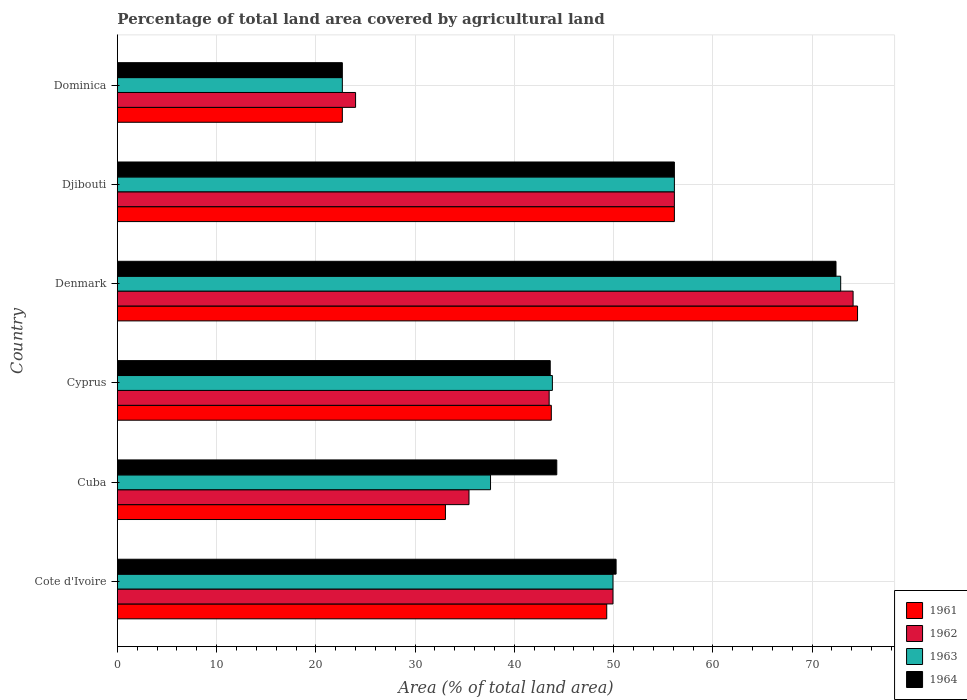Are the number of bars per tick equal to the number of legend labels?
Provide a succinct answer. Yes. Are the number of bars on each tick of the Y-axis equal?
Provide a short and direct response. Yes. How many bars are there on the 2nd tick from the top?
Ensure brevity in your answer.  4. How many bars are there on the 3rd tick from the bottom?
Provide a succinct answer. 4. What is the label of the 2nd group of bars from the top?
Your response must be concise. Djibouti. What is the percentage of agricultural land in 1963 in Cote d'Ivoire?
Your answer should be very brief. 49.94. Across all countries, what is the maximum percentage of agricultural land in 1962?
Give a very brief answer. 74.13. Across all countries, what is the minimum percentage of agricultural land in 1963?
Your response must be concise. 22.67. In which country was the percentage of agricultural land in 1962 maximum?
Give a very brief answer. Denmark. In which country was the percentage of agricultural land in 1964 minimum?
Provide a short and direct response. Dominica. What is the total percentage of agricultural land in 1962 in the graph?
Keep it short and to the point. 283.13. What is the difference between the percentage of agricultural land in 1963 in Denmark and that in Djibouti?
Provide a short and direct response. 16.76. What is the difference between the percentage of agricultural land in 1964 in Denmark and the percentage of agricultural land in 1961 in Djibouti?
Your response must be concise. 16.28. What is the average percentage of agricultural land in 1961 per country?
Offer a terse response. 46.58. What is the difference between the percentage of agricultural land in 1964 and percentage of agricultural land in 1963 in Cote d'Ivoire?
Offer a terse response. 0.31. In how many countries, is the percentage of agricultural land in 1964 greater than 24 %?
Give a very brief answer. 5. What is the ratio of the percentage of agricultural land in 1961 in Cyprus to that in Denmark?
Your answer should be very brief. 0.59. Is the difference between the percentage of agricultural land in 1964 in Cyprus and Djibouti greater than the difference between the percentage of agricultural land in 1963 in Cyprus and Djibouti?
Keep it short and to the point. No. What is the difference between the highest and the second highest percentage of agricultural land in 1964?
Offer a very short reply. 16.28. What is the difference between the highest and the lowest percentage of agricultural land in 1964?
Ensure brevity in your answer.  49.74. Is the sum of the percentage of agricultural land in 1962 in Cuba and Denmark greater than the maximum percentage of agricultural land in 1963 across all countries?
Make the answer very short. Yes. Is it the case that in every country, the sum of the percentage of agricultural land in 1962 and percentage of agricultural land in 1961 is greater than the sum of percentage of agricultural land in 1963 and percentage of agricultural land in 1964?
Provide a succinct answer. No. What does the 3rd bar from the bottom in Cuba represents?
Make the answer very short. 1963. How many bars are there?
Provide a short and direct response. 24. Are all the bars in the graph horizontal?
Provide a succinct answer. Yes. How many countries are there in the graph?
Your answer should be very brief. 6. Where does the legend appear in the graph?
Your answer should be compact. Bottom right. How many legend labels are there?
Make the answer very short. 4. How are the legend labels stacked?
Your answer should be very brief. Vertical. What is the title of the graph?
Offer a very short reply. Percentage of total land area covered by agricultural land. What is the label or title of the X-axis?
Keep it short and to the point. Area (% of total land area). What is the label or title of the Y-axis?
Ensure brevity in your answer.  Country. What is the Area (% of total land area) of 1961 in Cote d'Ivoire?
Offer a terse response. 49.31. What is the Area (% of total land area) in 1962 in Cote d'Ivoire?
Offer a very short reply. 49.94. What is the Area (% of total land area) of 1963 in Cote d'Ivoire?
Keep it short and to the point. 49.94. What is the Area (% of total land area) of 1964 in Cote d'Ivoire?
Keep it short and to the point. 50.25. What is the Area (% of total land area) of 1961 in Cuba?
Your answer should be very brief. 33.05. What is the Area (% of total land area) in 1962 in Cuba?
Your response must be concise. 35.43. What is the Area (% of total land area) in 1963 in Cuba?
Give a very brief answer. 37.6. What is the Area (% of total land area) in 1964 in Cuba?
Give a very brief answer. 44.27. What is the Area (% of total land area) of 1961 in Cyprus?
Offer a terse response. 43.72. What is the Area (% of total land area) of 1962 in Cyprus?
Offer a terse response. 43.51. What is the Area (% of total land area) in 1963 in Cyprus?
Give a very brief answer. 43.83. What is the Area (% of total land area) of 1964 in Cyprus?
Your answer should be compact. 43.61. What is the Area (% of total land area) in 1961 in Denmark?
Offer a very short reply. 74.58. What is the Area (% of total land area) in 1962 in Denmark?
Make the answer very short. 74.13. What is the Area (% of total land area) in 1963 in Denmark?
Offer a terse response. 72.88. What is the Area (% of total land area) in 1964 in Denmark?
Your answer should be compact. 72.41. What is the Area (% of total land area) in 1961 in Djibouti?
Make the answer very short. 56.13. What is the Area (% of total land area) in 1962 in Djibouti?
Offer a very short reply. 56.13. What is the Area (% of total land area) in 1963 in Djibouti?
Ensure brevity in your answer.  56.13. What is the Area (% of total land area) in 1964 in Djibouti?
Your response must be concise. 56.13. What is the Area (% of total land area) of 1961 in Dominica?
Your response must be concise. 22.67. What is the Area (% of total land area) in 1963 in Dominica?
Offer a terse response. 22.67. What is the Area (% of total land area) in 1964 in Dominica?
Offer a very short reply. 22.67. Across all countries, what is the maximum Area (% of total land area) of 1961?
Offer a very short reply. 74.58. Across all countries, what is the maximum Area (% of total land area) in 1962?
Your answer should be very brief. 74.13. Across all countries, what is the maximum Area (% of total land area) in 1963?
Provide a short and direct response. 72.88. Across all countries, what is the maximum Area (% of total land area) in 1964?
Make the answer very short. 72.41. Across all countries, what is the minimum Area (% of total land area) in 1961?
Offer a very short reply. 22.67. Across all countries, what is the minimum Area (% of total land area) in 1963?
Ensure brevity in your answer.  22.67. Across all countries, what is the minimum Area (% of total land area) in 1964?
Give a very brief answer. 22.67. What is the total Area (% of total land area) of 1961 in the graph?
Your answer should be compact. 279.46. What is the total Area (% of total land area) of 1962 in the graph?
Offer a very short reply. 283.13. What is the total Area (% of total land area) of 1963 in the graph?
Keep it short and to the point. 283.04. What is the total Area (% of total land area) in 1964 in the graph?
Provide a short and direct response. 289.34. What is the difference between the Area (% of total land area) of 1961 in Cote d'Ivoire and that in Cuba?
Provide a short and direct response. 16.25. What is the difference between the Area (% of total land area) in 1962 in Cote d'Ivoire and that in Cuba?
Provide a short and direct response. 14.51. What is the difference between the Area (% of total land area) in 1963 in Cote d'Ivoire and that in Cuba?
Provide a succinct answer. 12.34. What is the difference between the Area (% of total land area) of 1964 in Cote d'Ivoire and that in Cuba?
Provide a succinct answer. 5.98. What is the difference between the Area (% of total land area) in 1961 in Cote d'Ivoire and that in Cyprus?
Provide a succinct answer. 5.59. What is the difference between the Area (% of total land area) of 1962 in Cote d'Ivoire and that in Cyprus?
Keep it short and to the point. 6.43. What is the difference between the Area (% of total land area) of 1963 in Cote d'Ivoire and that in Cyprus?
Give a very brief answer. 6.11. What is the difference between the Area (% of total land area) of 1964 in Cote d'Ivoire and that in Cyprus?
Keep it short and to the point. 6.64. What is the difference between the Area (% of total land area) of 1961 in Cote d'Ivoire and that in Denmark?
Your response must be concise. -25.27. What is the difference between the Area (% of total land area) in 1962 in Cote d'Ivoire and that in Denmark?
Make the answer very short. -24.2. What is the difference between the Area (% of total land area) in 1963 in Cote d'Ivoire and that in Denmark?
Provide a short and direct response. -22.94. What is the difference between the Area (% of total land area) of 1964 in Cote d'Ivoire and that in Denmark?
Make the answer very short. -22.16. What is the difference between the Area (% of total land area) in 1961 in Cote d'Ivoire and that in Djibouti?
Your answer should be very brief. -6.82. What is the difference between the Area (% of total land area) in 1962 in Cote d'Ivoire and that in Djibouti?
Ensure brevity in your answer.  -6.19. What is the difference between the Area (% of total land area) of 1963 in Cote d'Ivoire and that in Djibouti?
Your response must be concise. -6.19. What is the difference between the Area (% of total land area) of 1964 in Cote d'Ivoire and that in Djibouti?
Your response must be concise. -5.87. What is the difference between the Area (% of total land area) in 1961 in Cote d'Ivoire and that in Dominica?
Give a very brief answer. 26.64. What is the difference between the Area (% of total land area) in 1962 in Cote d'Ivoire and that in Dominica?
Give a very brief answer. 25.94. What is the difference between the Area (% of total land area) of 1963 in Cote d'Ivoire and that in Dominica?
Offer a very short reply. 27.27. What is the difference between the Area (% of total land area) of 1964 in Cote d'Ivoire and that in Dominica?
Your answer should be compact. 27.58. What is the difference between the Area (% of total land area) in 1961 in Cuba and that in Cyprus?
Offer a very short reply. -10.67. What is the difference between the Area (% of total land area) in 1962 in Cuba and that in Cyprus?
Your answer should be very brief. -8.08. What is the difference between the Area (% of total land area) in 1963 in Cuba and that in Cyprus?
Make the answer very short. -6.23. What is the difference between the Area (% of total land area) of 1964 in Cuba and that in Cyprus?
Your answer should be very brief. 0.66. What is the difference between the Area (% of total land area) of 1961 in Cuba and that in Denmark?
Provide a succinct answer. -41.53. What is the difference between the Area (% of total land area) in 1962 in Cuba and that in Denmark?
Your answer should be compact. -38.7. What is the difference between the Area (% of total land area) of 1963 in Cuba and that in Denmark?
Offer a very short reply. -35.28. What is the difference between the Area (% of total land area) in 1964 in Cuba and that in Denmark?
Your response must be concise. -28.14. What is the difference between the Area (% of total land area) in 1961 in Cuba and that in Djibouti?
Offer a very short reply. -23.07. What is the difference between the Area (% of total land area) of 1962 in Cuba and that in Djibouti?
Provide a succinct answer. -20.7. What is the difference between the Area (% of total land area) of 1963 in Cuba and that in Djibouti?
Your answer should be very brief. -18.53. What is the difference between the Area (% of total land area) of 1964 in Cuba and that in Djibouti?
Your answer should be very brief. -11.85. What is the difference between the Area (% of total land area) in 1961 in Cuba and that in Dominica?
Offer a terse response. 10.39. What is the difference between the Area (% of total land area) in 1962 in Cuba and that in Dominica?
Make the answer very short. 11.43. What is the difference between the Area (% of total land area) of 1963 in Cuba and that in Dominica?
Give a very brief answer. 14.93. What is the difference between the Area (% of total land area) of 1964 in Cuba and that in Dominica?
Your answer should be very brief. 21.61. What is the difference between the Area (% of total land area) in 1961 in Cyprus and that in Denmark?
Make the answer very short. -30.86. What is the difference between the Area (% of total land area) in 1962 in Cyprus and that in Denmark?
Ensure brevity in your answer.  -30.63. What is the difference between the Area (% of total land area) in 1963 in Cyprus and that in Denmark?
Make the answer very short. -29.05. What is the difference between the Area (% of total land area) of 1964 in Cyprus and that in Denmark?
Keep it short and to the point. -28.8. What is the difference between the Area (% of total land area) in 1961 in Cyprus and that in Djibouti?
Offer a very short reply. -12.4. What is the difference between the Area (% of total land area) of 1962 in Cyprus and that in Djibouti?
Make the answer very short. -12.62. What is the difference between the Area (% of total land area) in 1963 in Cyprus and that in Djibouti?
Offer a very short reply. -12.29. What is the difference between the Area (% of total land area) in 1964 in Cyprus and that in Djibouti?
Your answer should be compact. -12.51. What is the difference between the Area (% of total land area) in 1961 in Cyprus and that in Dominica?
Offer a terse response. 21.06. What is the difference between the Area (% of total land area) of 1962 in Cyprus and that in Dominica?
Your answer should be compact. 19.51. What is the difference between the Area (% of total land area) of 1963 in Cyprus and that in Dominica?
Provide a short and direct response. 21.16. What is the difference between the Area (% of total land area) of 1964 in Cyprus and that in Dominica?
Offer a terse response. 20.95. What is the difference between the Area (% of total land area) of 1961 in Denmark and that in Djibouti?
Give a very brief answer. 18.46. What is the difference between the Area (% of total land area) in 1962 in Denmark and that in Djibouti?
Offer a very short reply. 18.01. What is the difference between the Area (% of total land area) in 1963 in Denmark and that in Djibouti?
Ensure brevity in your answer.  16.76. What is the difference between the Area (% of total land area) of 1964 in Denmark and that in Djibouti?
Your answer should be very brief. 16.28. What is the difference between the Area (% of total land area) of 1961 in Denmark and that in Dominica?
Provide a short and direct response. 51.91. What is the difference between the Area (% of total land area) in 1962 in Denmark and that in Dominica?
Your answer should be very brief. 50.13. What is the difference between the Area (% of total land area) of 1963 in Denmark and that in Dominica?
Your answer should be compact. 50.22. What is the difference between the Area (% of total land area) of 1964 in Denmark and that in Dominica?
Your response must be concise. 49.74. What is the difference between the Area (% of total land area) in 1961 in Djibouti and that in Dominica?
Offer a very short reply. 33.46. What is the difference between the Area (% of total land area) in 1962 in Djibouti and that in Dominica?
Make the answer very short. 32.13. What is the difference between the Area (% of total land area) of 1963 in Djibouti and that in Dominica?
Provide a succinct answer. 33.46. What is the difference between the Area (% of total land area) in 1964 in Djibouti and that in Dominica?
Provide a succinct answer. 33.46. What is the difference between the Area (% of total land area) of 1961 in Cote d'Ivoire and the Area (% of total land area) of 1962 in Cuba?
Provide a short and direct response. 13.88. What is the difference between the Area (% of total land area) of 1961 in Cote d'Ivoire and the Area (% of total land area) of 1963 in Cuba?
Make the answer very short. 11.71. What is the difference between the Area (% of total land area) of 1961 in Cote d'Ivoire and the Area (% of total land area) of 1964 in Cuba?
Your answer should be compact. 5.03. What is the difference between the Area (% of total land area) in 1962 in Cote d'Ivoire and the Area (% of total land area) in 1963 in Cuba?
Provide a succinct answer. 12.34. What is the difference between the Area (% of total land area) in 1962 in Cote d'Ivoire and the Area (% of total land area) in 1964 in Cuba?
Provide a short and direct response. 5.66. What is the difference between the Area (% of total land area) of 1963 in Cote d'Ivoire and the Area (% of total land area) of 1964 in Cuba?
Keep it short and to the point. 5.66. What is the difference between the Area (% of total land area) in 1961 in Cote d'Ivoire and the Area (% of total land area) in 1962 in Cyprus?
Offer a terse response. 5.8. What is the difference between the Area (% of total land area) in 1961 in Cote d'Ivoire and the Area (% of total land area) in 1963 in Cyprus?
Make the answer very short. 5.48. What is the difference between the Area (% of total land area) in 1961 in Cote d'Ivoire and the Area (% of total land area) in 1964 in Cyprus?
Offer a very short reply. 5.69. What is the difference between the Area (% of total land area) of 1962 in Cote d'Ivoire and the Area (% of total land area) of 1963 in Cyprus?
Offer a terse response. 6.11. What is the difference between the Area (% of total land area) of 1962 in Cote d'Ivoire and the Area (% of total land area) of 1964 in Cyprus?
Provide a succinct answer. 6.32. What is the difference between the Area (% of total land area) of 1963 in Cote d'Ivoire and the Area (% of total land area) of 1964 in Cyprus?
Your answer should be compact. 6.32. What is the difference between the Area (% of total land area) in 1961 in Cote d'Ivoire and the Area (% of total land area) in 1962 in Denmark?
Offer a terse response. -24.82. What is the difference between the Area (% of total land area) in 1961 in Cote d'Ivoire and the Area (% of total land area) in 1963 in Denmark?
Offer a terse response. -23.57. What is the difference between the Area (% of total land area) of 1961 in Cote d'Ivoire and the Area (% of total land area) of 1964 in Denmark?
Your answer should be very brief. -23.1. What is the difference between the Area (% of total land area) of 1962 in Cote d'Ivoire and the Area (% of total land area) of 1963 in Denmark?
Keep it short and to the point. -22.94. What is the difference between the Area (% of total land area) of 1962 in Cote d'Ivoire and the Area (% of total land area) of 1964 in Denmark?
Give a very brief answer. -22.47. What is the difference between the Area (% of total land area) of 1963 in Cote d'Ivoire and the Area (% of total land area) of 1964 in Denmark?
Your answer should be compact. -22.47. What is the difference between the Area (% of total land area) in 1961 in Cote d'Ivoire and the Area (% of total land area) in 1962 in Djibouti?
Ensure brevity in your answer.  -6.82. What is the difference between the Area (% of total land area) of 1961 in Cote d'Ivoire and the Area (% of total land area) of 1963 in Djibouti?
Provide a short and direct response. -6.82. What is the difference between the Area (% of total land area) of 1961 in Cote d'Ivoire and the Area (% of total land area) of 1964 in Djibouti?
Make the answer very short. -6.82. What is the difference between the Area (% of total land area) of 1962 in Cote d'Ivoire and the Area (% of total land area) of 1963 in Djibouti?
Your answer should be compact. -6.19. What is the difference between the Area (% of total land area) of 1962 in Cote d'Ivoire and the Area (% of total land area) of 1964 in Djibouti?
Your response must be concise. -6.19. What is the difference between the Area (% of total land area) of 1963 in Cote d'Ivoire and the Area (% of total land area) of 1964 in Djibouti?
Your response must be concise. -6.19. What is the difference between the Area (% of total land area) in 1961 in Cote d'Ivoire and the Area (% of total land area) in 1962 in Dominica?
Give a very brief answer. 25.31. What is the difference between the Area (% of total land area) in 1961 in Cote d'Ivoire and the Area (% of total land area) in 1963 in Dominica?
Provide a short and direct response. 26.64. What is the difference between the Area (% of total land area) in 1961 in Cote d'Ivoire and the Area (% of total land area) in 1964 in Dominica?
Ensure brevity in your answer.  26.64. What is the difference between the Area (% of total land area) in 1962 in Cote d'Ivoire and the Area (% of total land area) in 1963 in Dominica?
Offer a very short reply. 27.27. What is the difference between the Area (% of total land area) of 1962 in Cote d'Ivoire and the Area (% of total land area) of 1964 in Dominica?
Provide a short and direct response. 27.27. What is the difference between the Area (% of total land area) of 1963 in Cote d'Ivoire and the Area (% of total land area) of 1964 in Dominica?
Your answer should be compact. 27.27. What is the difference between the Area (% of total land area) in 1961 in Cuba and the Area (% of total land area) in 1962 in Cyprus?
Keep it short and to the point. -10.45. What is the difference between the Area (% of total land area) of 1961 in Cuba and the Area (% of total land area) of 1963 in Cyprus?
Your answer should be compact. -10.78. What is the difference between the Area (% of total land area) of 1961 in Cuba and the Area (% of total land area) of 1964 in Cyprus?
Provide a succinct answer. -10.56. What is the difference between the Area (% of total land area) in 1962 in Cuba and the Area (% of total land area) in 1963 in Cyprus?
Provide a short and direct response. -8.4. What is the difference between the Area (% of total land area) in 1962 in Cuba and the Area (% of total land area) in 1964 in Cyprus?
Your answer should be compact. -8.19. What is the difference between the Area (% of total land area) in 1963 in Cuba and the Area (% of total land area) in 1964 in Cyprus?
Ensure brevity in your answer.  -6.02. What is the difference between the Area (% of total land area) in 1961 in Cuba and the Area (% of total land area) in 1962 in Denmark?
Your answer should be very brief. -41.08. What is the difference between the Area (% of total land area) in 1961 in Cuba and the Area (% of total land area) in 1963 in Denmark?
Make the answer very short. -39.83. What is the difference between the Area (% of total land area) of 1961 in Cuba and the Area (% of total land area) of 1964 in Denmark?
Your response must be concise. -39.36. What is the difference between the Area (% of total land area) in 1962 in Cuba and the Area (% of total land area) in 1963 in Denmark?
Make the answer very short. -37.45. What is the difference between the Area (% of total land area) of 1962 in Cuba and the Area (% of total land area) of 1964 in Denmark?
Make the answer very short. -36.98. What is the difference between the Area (% of total land area) in 1963 in Cuba and the Area (% of total land area) in 1964 in Denmark?
Ensure brevity in your answer.  -34.81. What is the difference between the Area (% of total land area) of 1961 in Cuba and the Area (% of total land area) of 1962 in Djibouti?
Provide a short and direct response. -23.07. What is the difference between the Area (% of total land area) in 1961 in Cuba and the Area (% of total land area) in 1963 in Djibouti?
Ensure brevity in your answer.  -23.07. What is the difference between the Area (% of total land area) of 1961 in Cuba and the Area (% of total land area) of 1964 in Djibouti?
Make the answer very short. -23.07. What is the difference between the Area (% of total land area) in 1962 in Cuba and the Area (% of total land area) in 1963 in Djibouti?
Offer a very short reply. -20.7. What is the difference between the Area (% of total land area) in 1962 in Cuba and the Area (% of total land area) in 1964 in Djibouti?
Provide a short and direct response. -20.7. What is the difference between the Area (% of total land area) in 1963 in Cuba and the Area (% of total land area) in 1964 in Djibouti?
Make the answer very short. -18.53. What is the difference between the Area (% of total land area) in 1961 in Cuba and the Area (% of total land area) in 1962 in Dominica?
Provide a succinct answer. 9.05. What is the difference between the Area (% of total land area) in 1961 in Cuba and the Area (% of total land area) in 1963 in Dominica?
Ensure brevity in your answer.  10.39. What is the difference between the Area (% of total land area) in 1961 in Cuba and the Area (% of total land area) in 1964 in Dominica?
Offer a very short reply. 10.39. What is the difference between the Area (% of total land area) in 1962 in Cuba and the Area (% of total land area) in 1963 in Dominica?
Offer a terse response. 12.76. What is the difference between the Area (% of total land area) in 1962 in Cuba and the Area (% of total land area) in 1964 in Dominica?
Your answer should be compact. 12.76. What is the difference between the Area (% of total land area) in 1963 in Cuba and the Area (% of total land area) in 1964 in Dominica?
Your response must be concise. 14.93. What is the difference between the Area (% of total land area) in 1961 in Cyprus and the Area (% of total land area) in 1962 in Denmark?
Keep it short and to the point. -30.41. What is the difference between the Area (% of total land area) of 1961 in Cyprus and the Area (% of total land area) of 1963 in Denmark?
Ensure brevity in your answer.  -29.16. What is the difference between the Area (% of total land area) of 1961 in Cyprus and the Area (% of total land area) of 1964 in Denmark?
Offer a terse response. -28.69. What is the difference between the Area (% of total land area) in 1962 in Cyprus and the Area (% of total land area) in 1963 in Denmark?
Provide a short and direct response. -29.38. What is the difference between the Area (% of total land area) of 1962 in Cyprus and the Area (% of total land area) of 1964 in Denmark?
Keep it short and to the point. -28.9. What is the difference between the Area (% of total land area) in 1963 in Cyprus and the Area (% of total land area) in 1964 in Denmark?
Your response must be concise. -28.58. What is the difference between the Area (% of total land area) of 1961 in Cyprus and the Area (% of total land area) of 1962 in Djibouti?
Give a very brief answer. -12.4. What is the difference between the Area (% of total land area) in 1961 in Cyprus and the Area (% of total land area) in 1963 in Djibouti?
Your response must be concise. -12.4. What is the difference between the Area (% of total land area) in 1961 in Cyprus and the Area (% of total land area) in 1964 in Djibouti?
Make the answer very short. -12.4. What is the difference between the Area (% of total land area) of 1962 in Cyprus and the Area (% of total land area) of 1963 in Djibouti?
Give a very brief answer. -12.62. What is the difference between the Area (% of total land area) of 1962 in Cyprus and the Area (% of total land area) of 1964 in Djibouti?
Offer a very short reply. -12.62. What is the difference between the Area (% of total land area) of 1963 in Cyprus and the Area (% of total land area) of 1964 in Djibouti?
Your answer should be compact. -12.29. What is the difference between the Area (% of total land area) of 1961 in Cyprus and the Area (% of total land area) of 1962 in Dominica?
Keep it short and to the point. 19.72. What is the difference between the Area (% of total land area) in 1961 in Cyprus and the Area (% of total land area) in 1963 in Dominica?
Your answer should be compact. 21.06. What is the difference between the Area (% of total land area) in 1961 in Cyprus and the Area (% of total land area) in 1964 in Dominica?
Keep it short and to the point. 21.06. What is the difference between the Area (% of total land area) of 1962 in Cyprus and the Area (% of total land area) of 1963 in Dominica?
Offer a very short reply. 20.84. What is the difference between the Area (% of total land area) of 1962 in Cyprus and the Area (% of total land area) of 1964 in Dominica?
Your answer should be very brief. 20.84. What is the difference between the Area (% of total land area) of 1963 in Cyprus and the Area (% of total land area) of 1964 in Dominica?
Make the answer very short. 21.16. What is the difference between the Area (% of total land area) of 1961 in Denmark and the Area (% of total land area) of 1962 in Djibouti?
Give a very brief answer. 18.46. What is the difference between the Area (% of total land area) in 1961 in Denmark and the Area (% of total land area) in 1963 in Djibouti?
Your answer should be very brief. 18.46. What is the difference between the Area (% of total land area) of 1961 in Denmark and the Area (% of total land area) of 1964 in Djibouti?
Make the answer very short. 18.46. What is the difference between the Area (% of total land area) of 1962 in Denmark and the Area (% of total land area) of 1963 in Djibouti?
Offer a terse response. 18.01. What is the difference between the Area (% of total land area) in 1962 in Denmark and the Area (% of total land area) in 1964 in Djibouti?
Keep it short and to the point. 18.01. What is the difference between the Area (% of total land area) of 1963 in Denmark and the Area (% of total land area) of 1964 in Djibouti?
Make the answer very short. 16.76. What is the difference between the Area (% of total land area) in 1961 in Denmark and the Area (% of total land area) in 1962 in Dominica?
Your response must be concise. 50.58. What is the difference between the Area (% of total land area) of 1961 in Denmark and the Area (% of total land area) of 1963 in Dominica?
Ensure brevity in your answer.  51.91. What is the difference between the Area (% of total land area) of 1961 in Denmark and the Area (% of total land area) of 1964 in Dominica?
Make the answer very short. 51.91. What is the difference between the Area (% of total land area) of 1962 in Denmark and the Area (% of total land area) of 1963 in Dominica?
Your answer should be compact. 51.47. What is the difference between the Area (% of total land area) of 1962 in Denmark and the Area (% of total land area) of 1964 in Dominica?
Offer a very short reply. 51.47. What is the difference between the Area (% of total land area) in 1963 in Denmark and the Area (% of total land area) in 1964 in Dominica?
Provide a short and direct response. 50.22. What is the difference between the Area (% of total land area) of 1961 in Djibouti and the Area (% of total land area) of 1962 in Dominica?
Offer a very short reply. 32.13. What is the difference between the Area (% of total land area) in 1961 in Djibouti and the Area (% of total land area) in 1963 in Dominica?
Keep it short and to the point. 33.46. What is the difference between the Area (% of total land area) of 1961 in Djibouti and the Area (% of total land area) of 1964 in Dominica?
Make the answer very short. 33.46. What is the difference between the Area (% of total land area) in 1962 in Djibouti and the Area (% of total land area) in 1963 in Dominica?
Offer a very short reply. 33.46. What is the difference between the Area (% of total land area) in 1962 in Djibouti and the Area (% of total land area) in 1964 in Dominica?
Give a very brief answer. 33.46. What is the difference between the Area (% of total land area) of 1963 in Djibouti and the Area (% of total land area) of 1964 in Dominica?
Your response must be concise. 33.46. What is the average Area (% of total land area) of 1961 per country?
Make the answer very short. 46.58. What is the average Area (% of total land area) in 1962 per country?
Your answer should be very brief. 47.19. What is the average Area (% of total land area) in 1963 per country?
Your answer should be very brief. 47.17. What is the average Area (% of total land area) in 1964 per country?
Provide a short and direct response. 48.22. What is the difference between the Area (% of total land area) in 1961 and Area (% of total land area) in 1962 in Cote d'Ivoire?
Keep it short and to the point. -0.63. What is the difference between the Area (% of total land area) of 1961 and Area (% of total land area) of 1963 in Cote d'Ivoire?
Ensure brevity in your answer.  -0.63. What is the difference between the Area (% of total land area) in 1961 and Area (% of total land area) in 1964 in Cote d'Ivoire?
Make the answer very short. -0.94. What is the difference between the Area (% of total land area) in 1962 and Area (% of total land area) in 1964 in Cote d'Ivoire?
Your answer should be very brief. -0.31. What is the difference between the Area (% of total land area) in 1963 and Area (% of total land area) in 1964 in Cote d'Ivoire?
Ensure brevity in your answer.  -0.31. What is the difference between the Area (% of total land area) of 1961 and Area (% of total land area) of 1962 in Cuba?
Your answer should be very brief. -2.37. What is the difference between the Area (% of total land area) of 1961 and Area (% of total land area) of 1963 in Cuba?
Ensure brevity in your answer.  -4.54. What is the difference between the Area (% of total land area) in 1961 and Area (% of total land area) in 1964 in Cuba?
Provide a short and direct response. -11.22. What is the difference between the Area (% of total land area) of 1962 and Area (% of total land area) of 1963 in Cuba?
Provide a succinct answer. -2.17. What is the difference between the Area (% of total land area) in 1962 and Area (% of total land area) in 1964 in Cuba?
Offer a terse response. -8.85. What is the difference between the Area (% of total land area) of 1963 and Area (% of total land area) of 1964 in Cuba?
Provide a short and direct response. -6.68. What is the difference between the Area (% of total land area) in 1961 and Area (% of total land area) in 1962 in Cyprus?
Offer a very short reply. 0.22. What is the difference between the Area (% of total land area) in 1961 and Area (% of total land area) in 1963 in Cyprus?
Your answer should be compact. -0.11. What is the difference between the Area (% of total land area) in 1961 and Area (% of total land area) in 1964 in Cyprus?
Offer a terse response. 0.11. What is the difference between the Area (% of total land area) of 1962 and Area (% of total land area) of 1963 in Cyprus?
Provide a succinct answer. -0.32. What is the difference between the Area (% of total land area) in 1962 and Area (% of total land area) in 1964 in Cyprus?
Ensure brevity in your answer.  -0.11. What is the difference between the Area (% of total land area) in 1963 and Area (% of total land area) in 1964 in Cyprus?
Keep it short and to the point. 0.22. What is the difference between the Area (% of total land area) of 1961 and Area (% of total land area) of 1962 in Denmark?
Your answer should be very brief. 0.45. What is the difference between the Area (% of total land area) of 1961 and Area (% of total land area) of 1963 in Denmark?
Your response must be concise. 1.7. What is the difference between the Area (% of total land area) in 1961 and Area (% of total land area) in 1964 in Denmark?
Your response must be concise. 2.17. What is the difference between the Area (% of total land area) in 1962 and Area (% of total land area) in 1963 in Denmark?
Keep it short and to the point. 1.25. What is the difference between the Area (% of total land area) of 1962 and Area (% of total land area) of 1964 in Denmark?
Provide a short and direct response. 1.72. What is the difference between the Area (% of total land area) of 1963 and Area (% of total land area) of 1964 in Denmark?
Make the answer very short. 0.47. What is the difference between the Area (% of total land area) in 1961 and Area (% of total land area) in 1962 in Djibouti?
Give a very brief answer. 0. What is the difference between the Area (% of total land area) of 1961 and Area (% of total land area) of 1964 in Djibouti?
Make the answer very short. 0. What is the difference between the Area (% of total land area) in 1961 and Area (% of total land area) in 1962 in Dominica?
Ensure brevity in your answer.  -1.33. What is the difference between the Area (% of total land area) in 1961 and Area (% of total land area) in 1963 in Dominica?
Provide a short and direct response. 0. What is the difference between the Area (% of total land area) of 1962 and Area (% of total land area) of 1964 in Dominica?
Ensure brevity in your answer.  1.33. What is the ratio of the Area (% of total land area) of 1961 in Cote d'Ivoire to that in Cuba?
Make the answer very short. 1.49. What is the ratio of the Area (% of total land area) of 1962 in Cote d'Ivoire to that in Cuba?
Offer a very short reply. 1.41. What is the ratio of the Area (% of total land area) of 1963 in Cote d'Ivoire to that in Cuba?
Your response must be concise. 1.33. What is the ratio of the Area (% of total land area) of 1964 in Cote d'Ivoire to that in Cuba?
Give a very brief answer. 1.14. What is the ratio of the Area (% of total land area) of 1961 in Cote d'Ivoire to that in Cyprus?
Your response must be concise. 1.13. What is the ratio of the Area (% of total land area) in 1962 in Cote d'Ivoire to that in Cyprus?
Offer a terse response. 1.15. What is the ratio of the Area (% of total land area) in 1963 in Cote d'Ivoire to that in Cyprus?
Give a very brief answer. 1.14. What is the ratio of the Area (% of total land area) in 1964 in Cote d'Ivoire to that in Cyprus?
Your answer should be very brief. 1.15. What is the ratio of the Area (% of total land area) of 1961 in Cote d'Ivoire to that in Denmark?
Your response must be concise. 0.66. What is the ratio of the Area (% of total land area) of 1962 in Cote d'Ivoire to that in Denmark?
Provide a short and direct response. 0.67. What is the ratio of the Area (% of total land area) in 1963 in Cote d'Ivoire to that in Denmark?
Offer a terse response. 0.69. What is the ratio of the Area (% of total land area) of 1964 in Cote d'Ivoire to that in Denmark?
Ensure brevity in your answer.  0.69. What is the ratio of the Area (% of total land area) in 1961 in Cote d'Ivoire to that in Djibouti?
Keep it short and to the point. 0.88. What is the ratio of the Area (% of total land area) of 1962 in Cote d'Ivoire to that in Djibouti?
Provide a succinct answer. 0.89. What is the ratio of the Area (% of total land area) in 1963 in Cote d'Ivoire to that in Djibouti?
Offer a terse response. 0.89. What is the ratio of the Area (% of total land area) of 1964 in Cote d'Ivoire to that in Djibouti?
Your response must be concise. 0.9. What is the ratio of the Area (% of total land area) in 1961 in Cote d'Ivoire to that in Dominica?
Offer a terse response. 2.18. What is the ratio of the Area (% of total land area) in 1962 in Cote d'Ivoire to that in Dominica?
Ensure brevity in your answer.  2.08. What is the ratio of the Area (% of total land area) in 1963 in Cote d'Ivoire to that in Dominica?
Provide a succinct answer. 2.2. What is the ratio of the Area (% of total land area) of 1964 in Cote d'Ivoire to that in Dominica?
Make the answer very short. 2.22. What is the ratio of the Area (% of total land area) in 1961 in Cuba to that in Cyprus?
Offer a very short reply. 0.76. What is the ratio of the Area (% of total land area) of 1962 in Cuba to that in Cyprus?
Provide a succinct answer. 0.81. What is the ratio of the Area (% of total land area) in 1963 in Cuba to that in Cyprus?
Your answer should be very brief. 0.86. What is the ratio of the Area (% of total land area) of 1964 in Cuba to that in Cyprus?
Your response must be concise. 1.02. What is the ratio of the Area (% of total land area) in 1961 in Cuba to that in Denmark?
Provide a short and direct response. 0.44. What is the ratio of the Area (% of total land area) of 1962 in Cuba to that in Denmark?
Offer a very short reply. 0.48. What is the ratio of the Area (% of total land area) of 1963 in Cuba to that in Denmark?
Ensure brevity in your answer.  0.52. What is the ratio of the Area (% of total land area) in 1964 in Cuba to that in Denmark?
Offer a very short reply. 0.61. What is the ratio of the Area (% of total land area) of 1961 in Cuba to that in Djibouti?
Provide a succinct answer. 0.59. What is the ratio of the Area (% of total land area) of 1962 in Cuba to that in Djibouti?
Give a very brief answer. 0.63. What is the ratio of the Area (% of total land area) in 1963 in Cuba to that in Djibouti?
Give a very brief answer. 0.67. What is the ratio of the Area (% of total land area) of 1964 in Cuba to that in Djibouti?
Your response must be concise. 0.79. What is the ratio of the Area (% of total land area) of 1961 in Cuba to that in Dominica?
Keep it short and to the point. 1.46. What is the ratio of the Area (% of total land area) in 1962 in Cuba to that in Dominica?
Make the answer very short. 1.48. What is the ratio of the Area (% of total land area) in 1963 in Cuba to that in Dominica?
Offer a very short reply. 1.66. What is the ratio of the Area (% of total land area) in 1964 in Cuba to that in Dominica?
Offer a terse response. 1.95. What is the ratio of the Area (% of total land area) of 1961 in Cyprus to that in Denmark?
Make the answer very short. 0.59. What is the ratio of the Area (% of total land area) in 1962 in Cyprus to that in Denmark?
Ensure brevity in your answer.  0.59. What is the ratio of the Area (% of total land area) of 1963 in Cyprus to that in Denmark?
Give a very brief answer. 0.6. What is the ratio of the Area (% of total land area) of 1964 in Cyprus to that in Denmark?
Offer a very short reply. 0.6. What is the ratio of the Area (% of total land area) in 1961 in Cyprus to that in Djibouti?
Ensure brevity in your answer.  0.78. What is the ratio of the Area (% of total land area) of 1962 in Cyprus to that in Djibouti?
Your answer should be very brief. 0.78. What is the ratio of the Area (% of total land area) of 1963 in Cyprus to that in Djibouti?
Your answer should be compact. 0.78. What is the ratio of the Area (% of total land area) in 1964 in Cyprus to that in Djibouti?
Your response must be concise. 0.78. What is the ratio of the Area (% of total land area) in 1961 in Cyprus to that in Dominica?
Your response must be concise. 1.93. What is the ratio of the Area (% of total land area) in 1962 in Cyprus to that in Dominica?
Make the answer very short. 1.81. What is the ratio of the Area (% of total land area) in 1963 in Cyprus to that in Dominica?
Offer a very short reply. 1.93. What is the ratio of the Area (% of total land area) of 1964 in Cyprus to that in Dominica?
Provide a short and direct response. 1.92. What is the ratio of the Area (% of total land area) in 1961 in Denmark to that in Djibouti?
Your answer should be very brief. 1.33. What is the ratio of the Area (% of total land area) in 1962 in Denmark to that in Djibouti?
Make the answer very short. 1.32. What is the ratio of the Area (% of total land area) of 1963 in Denmark to that in Djibouti?
Your answer should be very brief. 1.3. What is the ratio of the Area (% of total land area) in 1964 in Denmark to that in Djibouti?
Give a very brief answer. 1.29. What is the ratio of the Area (% of total land area) of 1961 in Denmark to that in Dominica?
Give a very brief answer. 3.29. What is the ratio of the Area (% of total land area) of 1962 in Denmark to that in Dominica?
Make the answer very short. 3.09. What is the ratio of the Area (% of total land area) of 1963 in Denmark to that in Dominica?
Your answer should be compact. 3.22. What is the ratio of the Area (% of total land area) in 1964 in Denmark to that in Dominica?
Give a very brief answer. 3.19. What is the ratio of the Area (% of total land area) in 1961 in Djibouti to that in Dominica?
Your response must be concise. 2.48. What is the ratio of the Area (% of total land area) in 1962 in Djibouti to that in Dominica?
Provide a short and direct response. 2.34. What is the ratio of the Area (% of total land area) in 1963 in Djibouti to that in Dominica?
Keep it short and to the point. 2.48. What is the ratio of the Area (% of total land area) of 1964 in Djibouti to that in Dominica?
Provide a succinct answer. 2.48. What is the difference between the highest and the second highest Area (% of total land area) of 1961?
Provide a short and direct response. 18.46. What is the difference between the highest and the second highest Area (% of total land area) in 1962?
Provide a succinct answer. 18.01. What is the difference between the highest and the second highest Area (% of total land area) of 1963?
Keep it short and to the point. 16.76. What is the difference between the highest and the second highest Area (% of total land area) in 1964?
Give a very brief answer. 16.28. What is the difference between the highest and the lowest Area (% of total land area) in 1961?
Provide a succinct answer. 51.91. What is the difference between the highest and the lowest Area (% of total land area) in 1962?
Ensure brevity in your answer.  50.13. What is the difference between the highest and the lowest Area (% of total land area) in 1963?
Your answer should be compact. 50.22. What is the difference between the highest and the lowest Area (% of total land area) in 1964?
Offer a terse response. 49.74. 